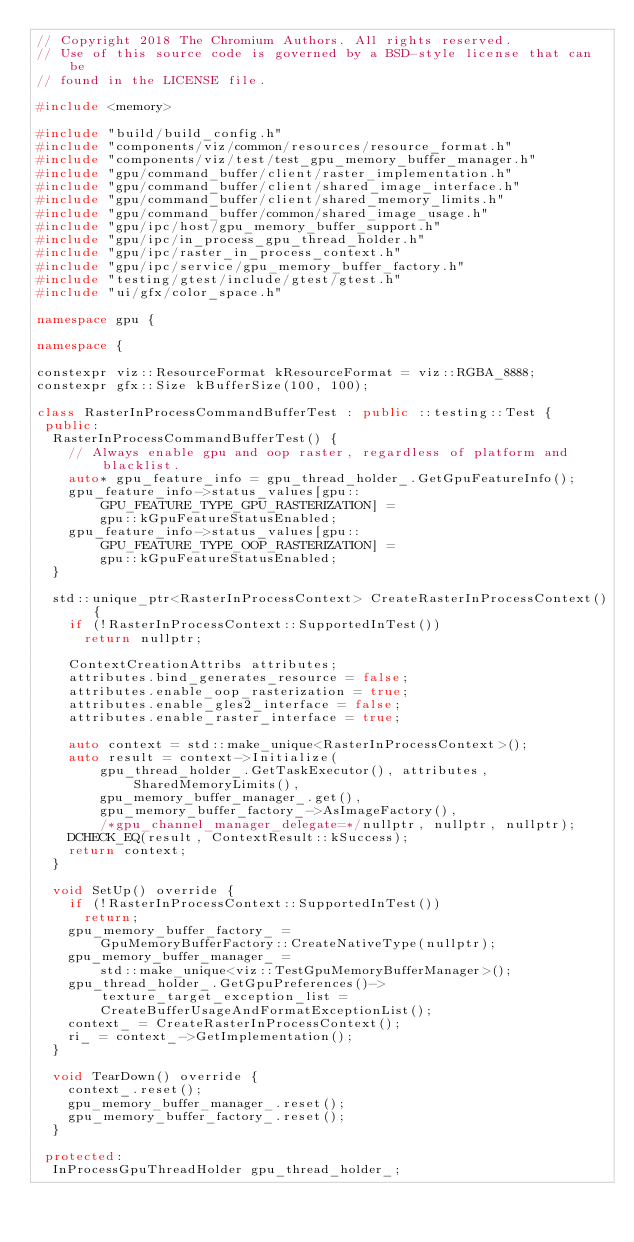Convert code to text. <code><loc_0><loc_0><loc_500><loc_500><_C++_>// Copyright 2018 The Chromium Authors. All rights reserved.
// Use of this source code is governed by a BSD-style license that can be
// found in the LICENSE file.

#include <memory>

#include "build/build_config.h"
#include "components/viz/common/resources/resource_format.h"
#include "components/viz/test/test_gpu_memory_buffer_manager.h"
#include "gpu/command_buffer/client/raster_implementation.h"
#include "gpu/command_buffer/client/shared_image_interface.h"
#include "gpu/command_buffer/client/shared_memory_limits.h"
#include "gpu/command_buffer/common/shared_image_usage.h"
#include "gpu/ipc/host/gpu_memory_buffer_support.h"
#include "gpu/ipc/in_process_gpu_thread_holder.h"
#include "gpu/ipc/raster_in_process_context.h"
#include "gpu/ipc/service/gpu_memory_buffer_factory.h"
#include "testing/gtest/include/gtest/gtest.h"
#include "ui/gfx/color_space.h"

namespace gpu {

namespace {

constexpr viz::ResourceFormat kResourceFormat = viz::RGBA_8888;
constexpr gfx::Size kBufferSize(100, 100);

class RasterInProcessCommandBufferTest : public ::testing::Test {
 public:
  RasterInProcessCommandBufferTest() {
    // Always enable gpu and oop raster, regardless of platform and blacklist.
    auto* gpu_feature_info = gpu_thread_holder_.GetGpuFeatureInfo();
    gpu_feature_info->status_values[gpu::GPU_FEATURE_TYPE_GPU_RASTERIZATION] =
        gpu::kGpuFeatureStatusEnabled;
    gpu_feature_info->status_values[gpu::GPU_FEATURE_TYPE_OOP_RASTERIZATION] =
        gpu::kGpuFeatureStatusEnabled;
  }

  std::unique_ptr<RasterInProcessContext> CreateRasterInProcessContext() {
    if (!RasterInProcessContext::SupportedInTest())
      return nullptr;

    ContextCreationAttribs attributes;
    attributes.bind_generates_resource = false;
    attributes.enable_oop_rasterization = true;
    attributes.enable_gles2_interface = false;
    attributes.enable_raster_interface = true;

    auto context = std::make_unique<RasterInProcessContext>();
    auto result = context->Initialize(
        gpu_thread_holder_.GetTaskExecutor(), attributes, SharedMemoryLimits(),
        gpu_memory_buffer_manager_.get(),
        gpu_memory_buffer_factory_->AsImageFactory(),
        /*gpu_channel_manager_delegate=*/nullptr, nullptr, nullptr);
    DCHECK_EQ(result, ContextResult::kSuccess);
    return context;
  }

  void SetUp() override {
    if (!RasterInProcessContext::SupportedInTest())
      return;
    gpu_memory_buffer_factory_ =
        GpuMemoryBufferFactory::CreateNativeType(nullptr);
    gpu_memory_buffer_manager_ =
        std::make_unique<viz::TestGpuMemoryBufferManager>();
    gpu_thread_holder_.GetGpuPreferences()->texture_target_exception_list =
        CreateBufferUsageAndFormatExceptionList();
    context_ = CreateRasterInProcessContext();
    ri_ = context_->GetImplementation();
  }

  void TearDown() override {
    context_.reset();
    gpu_memory_buffer_manager_.reset();
    gpu_memory_buffer_factory_.reset();
  }

 protected:
  InProcessGpuThreadHolder gpu_thread_holder_;</code> 